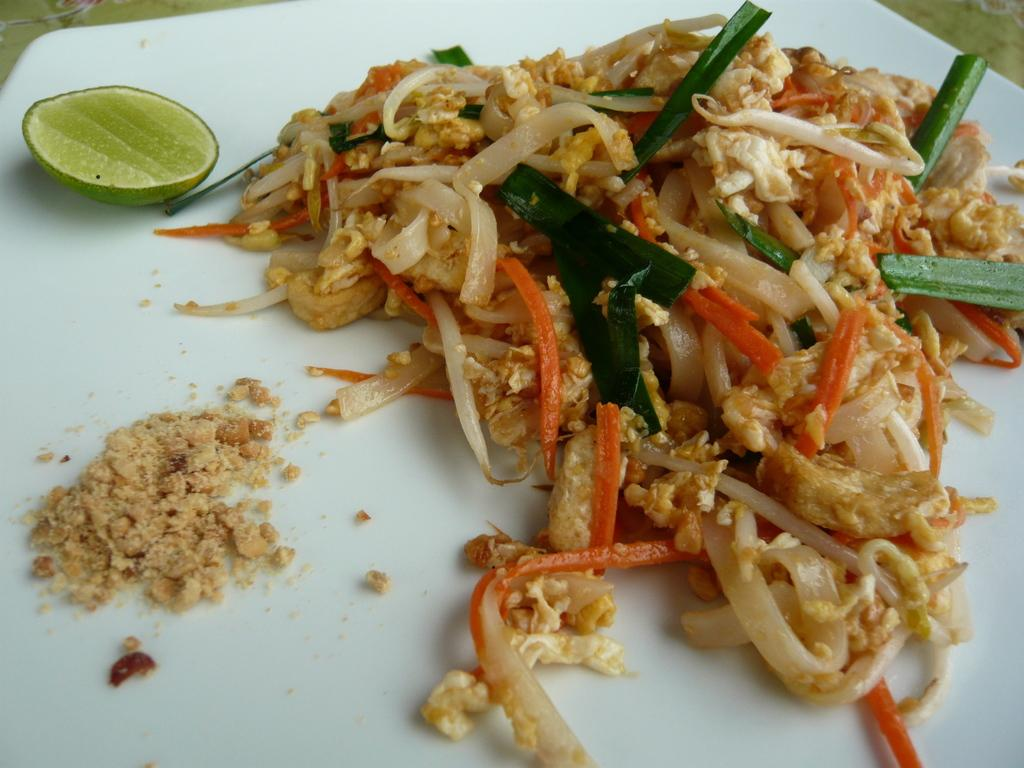What type of food is depicted in the image? There are noodles in the image. What additional ingredients are included with the noodles? The noodles have carrot and leaves. What other food item can be seen in the image? There is a lemon in the image. What color is the plate that the noodles are on? The plate is white. What type of sweater is being worn by the lemon in the image? There is no sweater present in the image, as the lemon is a fruit and not a person or animate object. 